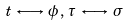<formula> <loc_0><loc_0><loc_500><loc_500>t \, \longleftrightarrow \, \phi \, , \, \tau \, \longleftrightarrow \, \sigma</formula> 